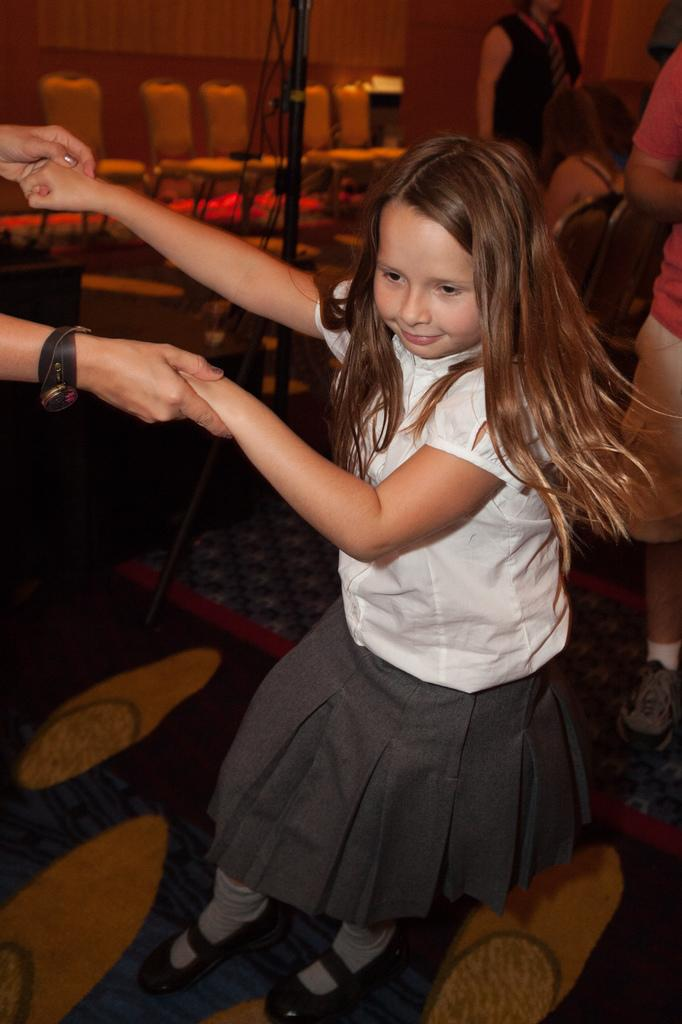Who is the main subject in the image? There is a girl in the center of the image. What is located at the bottom of the image? There is a carpet at the bottom of the image. What can be seen in the background of the image? There are chairs in the background of the image. How many people are present in the image? There are people in the image. What type of island can be seen in the background of the image? There is no island present in the image; it features a girl, a carpet, chairs, and people. Is the queen visible in the image? There is no queen present in the image. 